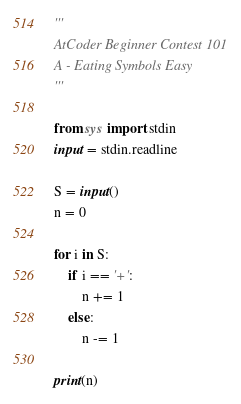<code> <loc_0><loc_0><loc_500><loc_500><_Python_>'''
AtCoder Beginner Contest 101
A - Eating Symbols Easy
'''

from sys import stdin
input = stdin.readline

S = input()
n = 0

for i in S:
    if i == '+':
        n += 1
    else:
        n -= 1

print(n)</code> 